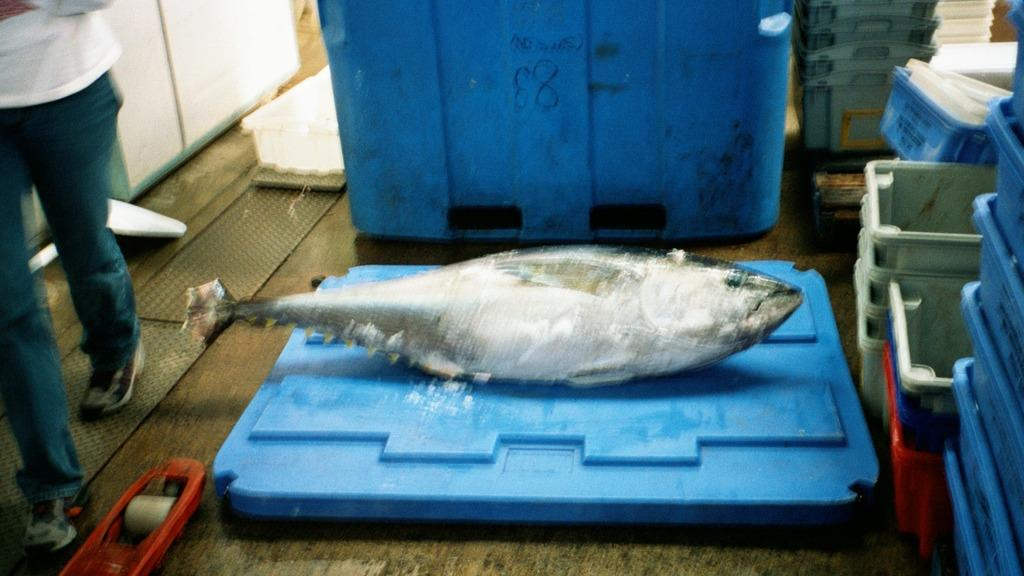What type of animal is in the image? There is a fish in the image. What is happening on the left side of the image? There is a person walking on the left side of the image. What objects can be seen on the right side of the image? There are trays on the right side of the image. What type of dinner is being celebrated in the image? There is no dinner or celebration present in the image; it only features a fish, a person walking, and trays. How high are the waves in the image? There are no waves present in the image. 